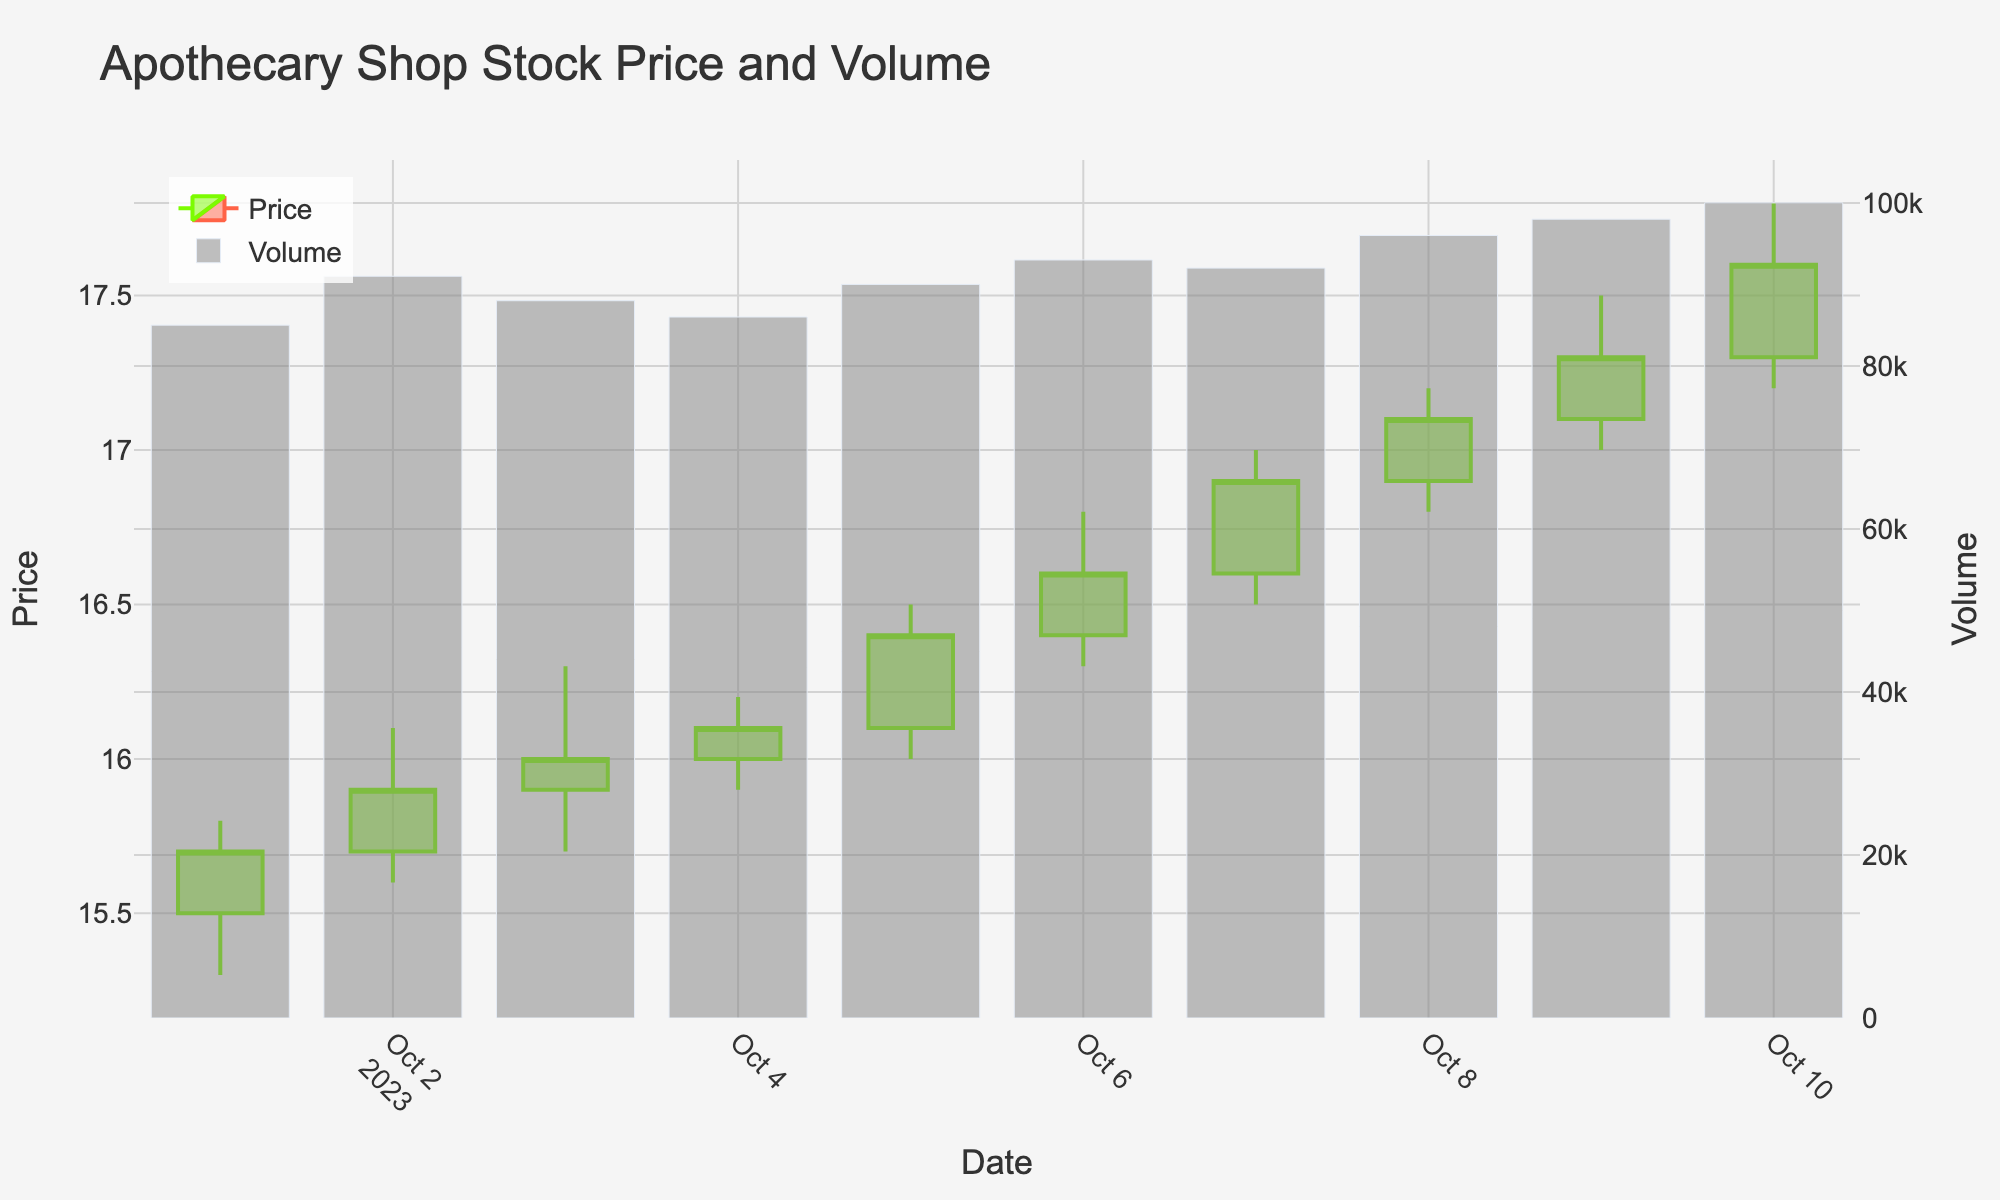What is the title of the plot? The title of the plot is displayed at the top and reads "Apothecary Shop Stock Price and Volume".
Answer: Apothecary Shop Stock Price and Volume How many trading days are shown in the plot? The x-axis shows dates from October 1, 2023, to October 10, 2023, covering ten trading days.
Answer: 10 On which date was the trading volume the highest? The bar for October 10 is the tallest amongst the volume bars, indicating the highest trading volume.
Answer: October 10, 2023 What was the closing price on October 3, 2023? The closing price for October 3 is derived from the top of the candlestick body for that date, which is 16.00.
Answer: 16.00 On which date did the stock experience the greatest price fluctuation? Price fluctuation can be found by subtracting the low from the high for each day. October 10's fluctuation is 17.80 - 17.20 = 0.60. Other days have lesser fluctuations.
Answer: October 10, 2023 How did the price trend from October 1 to October 10? Reviewing the closing prices each day shows an overall increasing trend starting at 15.70 and ending at 17.60 on October 10.
Answer: Increasing What was the total trading volume over the entire period? Summing up the volume for each day: 85000 + 91000 + 88000 + 86000 + 90000 + 93000 + 92000 + 96000 + 98000 + 100000 = 897000.
Answer: 897000 Which day had the smallest difference between the opening and closing prices? Check the absolute difference between the opening and closing prices for each day: October 4 had the smallest difference (0.10).
Answer: October 4, 2023 Compare the overall daily volume trend to the price trend. Are they consistent? Both volume and prices generally show an increasing trend over time, suggesting consistency between trading activity and price movement.
Answer: Yes What color represents days when the stock price increased? Green is used to represent days on which the stock price increased from the opening to the closing price.
Answer: Green 